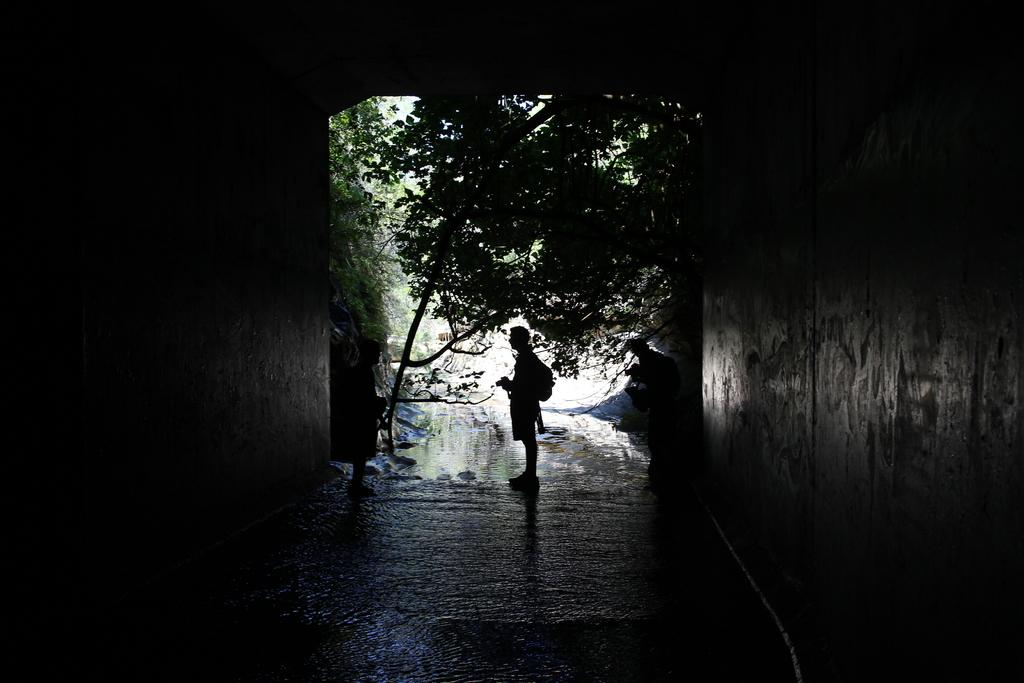What is the main feature in the image? There is a tunnel in the image. How many people are present in the image? There are three persons in the image. What can be seen besides the tunnel? There is a path in the image. What can be seen in the background of the image? There is water and trees visible in the background of the image. What type of blade is being used by the person in the image? There is no blade present in the image; the three persons are not using any tools or objects. 